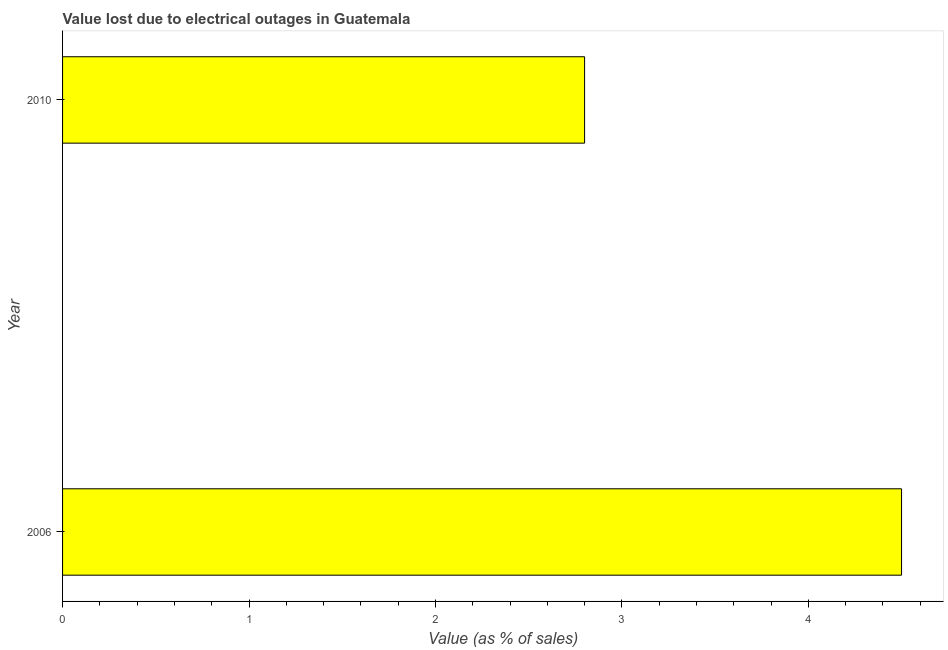What is the title of the graph?
Your response must be concise. Value lost due to electrical outages in Guatemala. What is the label or title of the X-axis?
Give a very brief answer. Value (as % of sales). What is the label or title of the Y-axis?
Offer a very short reply. Year. What is the value lost due to electrical outages in 2006?
Your response must be concise. 4.5. Across all years, what is the minimum value lost due to electrical outages?
Give a very brief answer. 2.8. In which year was the value lost due to electrical outages maximum?
Offer a very short reply. 2006. What is the sum of the value lost due to electrical outages?
Offer a very short reply. 7.3. What is the average value lost due to electrical outages per year?
Provide a succinct answer. 3.65. What is the median value lost due to electrical outages?
Ensure brevity in your answer.  3.65. In how many years, is the value lost due to electrical outages greater than 4.2 %?
Ensure brevity in your answer.  1. Do a majority of the years between 2006 and 2010 (inclusive) have value lost due to electrical outages greater than 1.8 %?
Give a very brief answer. Yes. What is the ratio of the value lost due to electrical outages in 2006 to that in 2010?
Your answer should be compact. 1.61. How many bars are there?
Offer a very short reply. 2. Are all the bars in the graph horizontal?
Keep it short and to the point. Yes. How many years are there in the graph?
Your answer should be very brief. 2. What is the difference between two consecutive major ticks on the X-axis?
Your response must be concise. 1. Are the values on the major ticks of X-axis written in scientific E-notation?
Your answer should be very brief. No. What is the Value (as % of sales) of 2010?
Offer a terse response. 2.8. What is the ratio of the Value (as % of sales) in 2006 to that in 2010?
Your response must be concise. 1.61. 